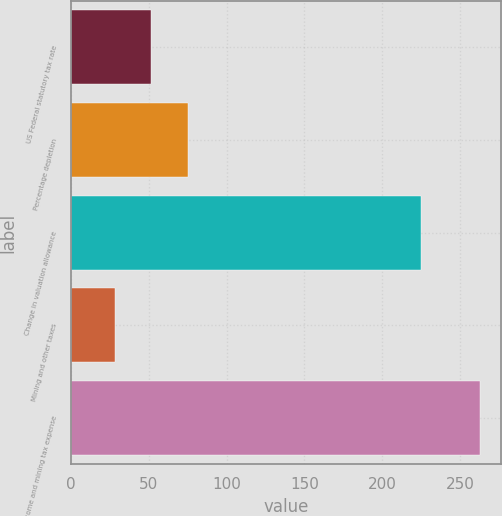Convert chart to OTSL. <chart><loc_0><loc_0><loc_500><loc_500><bar_chart><fcel>US Federal statutory tax rate<fcel>Percentage depletion<fcel>Change in valuation allowance<fcel>Mining and other taxes<fcel>Income and mining tax expense<nl><fcel>51.5<fcel>75<fcel>225<fcel>28<fcel>263<nl></chart> 